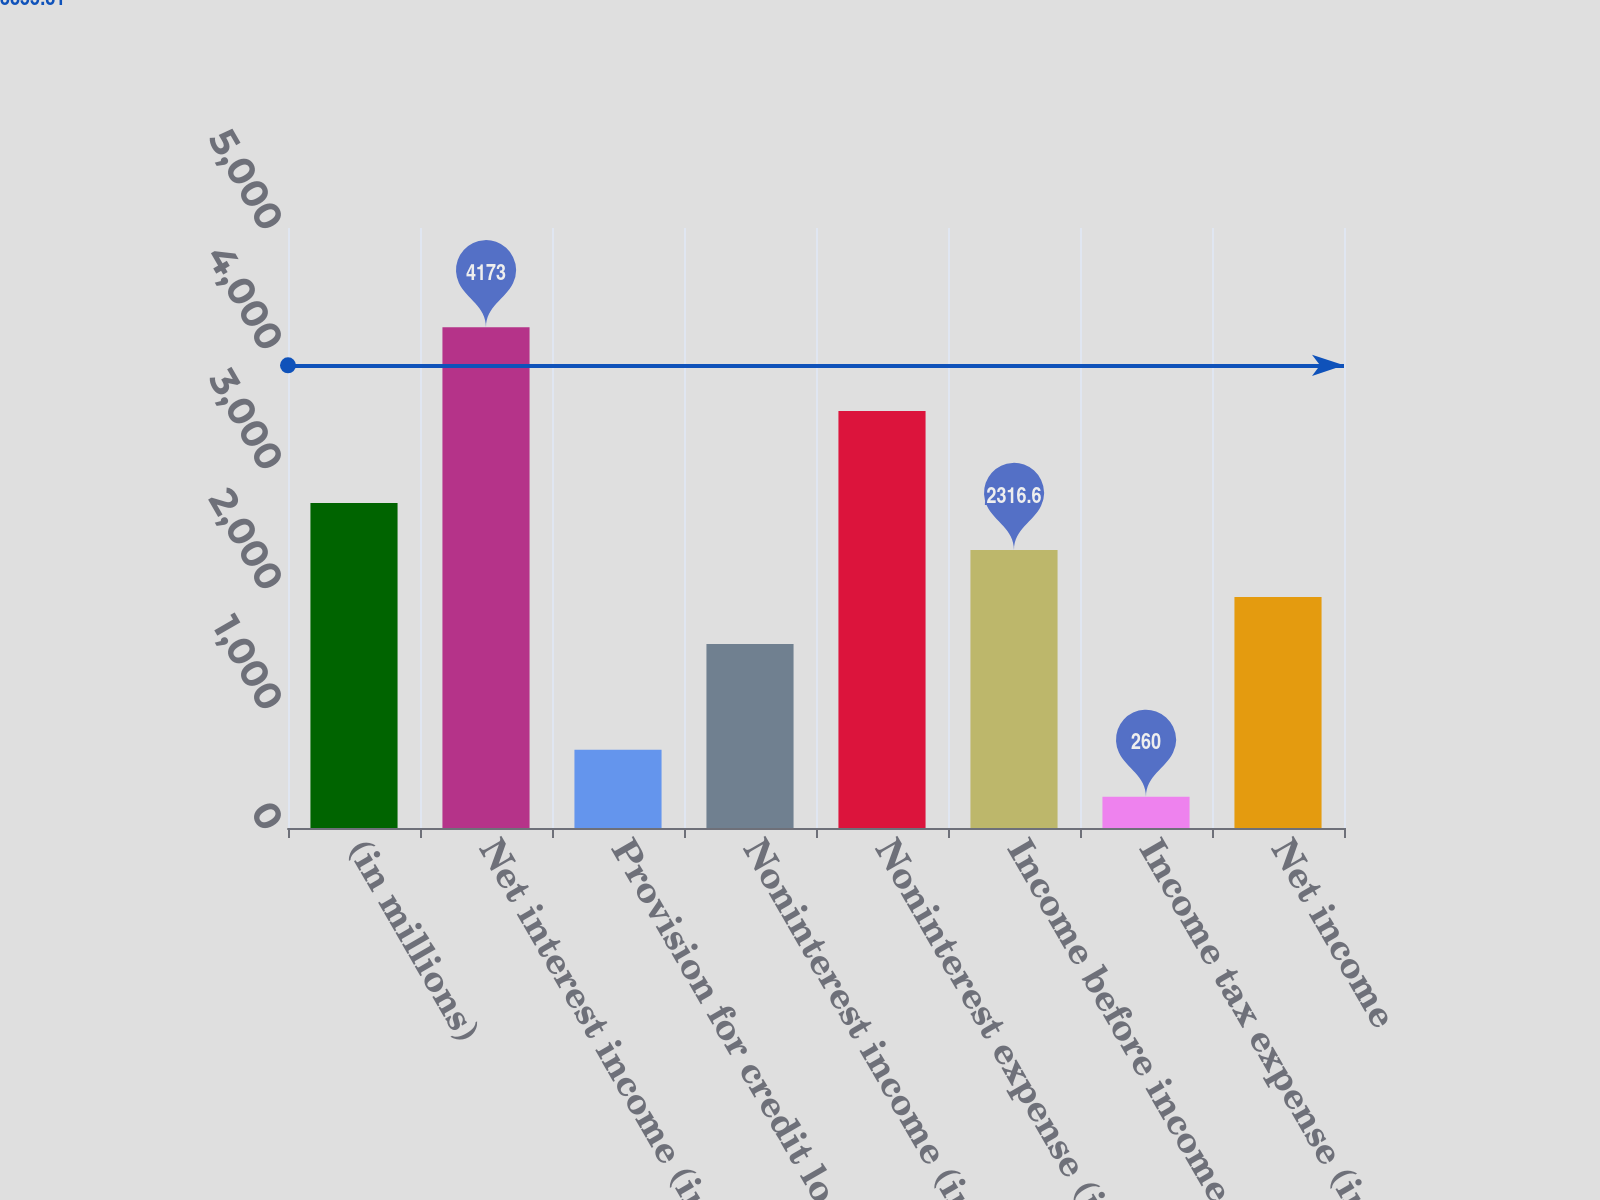Convert chart to OTSL. <chart><loc_0><loc_0><loc_500><loc_500><bar_chart><fcel>(in millions)<fcel>Net interest income (includes<fcel>Provision for credit losses<fcel>Noninterest income (includes 4<fcel>Noninterest expense (includes<fcel>Income before income tax<fcel>Income tax expense (includes<fcel>Net income<nl><fcel>2707.9<fcel>4173<fcel>651.3<fcel>1534<fcel>3474<fcel>2316.6<fcel>260<fcel>1925.3<nl></chart> 